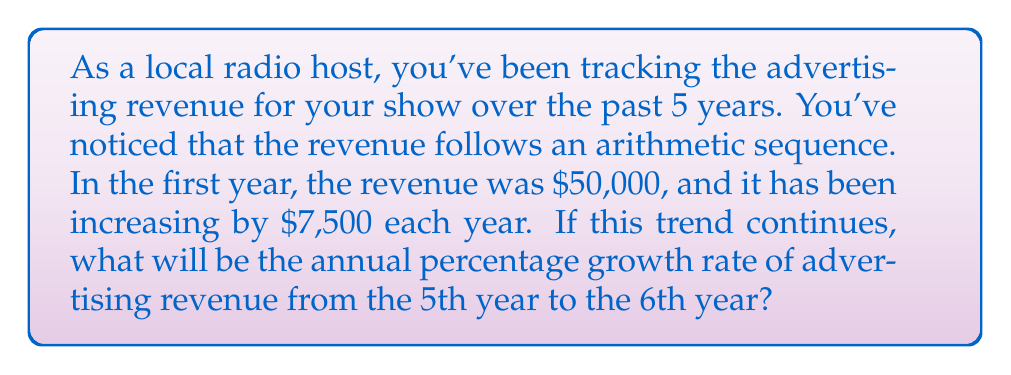What is the answer to this math problem? Let's approach this step-by-step:

1) First, we need to find the revenue for the 5th and 6th years.

   The arithmetic sequence is given by:
   $$a_n = a_1 + (n-1)d$$
   where $a_n$ is the nth term, $a_1$ is the first term, $n$ is the term number, and $d$ is the common difference.

2) For the 5th year:
   $$a_5 = 50000 + (5-1) * 7500 = 50000 + 30000 = 80000$$

3) For the 6th year:
   $$a_6 = 50000 + (6-1) * 7500 = 50000 + 37500 = 87500$$

4) To calculate the percentage growth rate, we use the formula:
   $$\text{Growth Rate} = \frac{\text{New Value} - \text{Original Value}}{\text{Original Value}} * 100\%$$

5) Plugging in our values:
   $$\text{Growth Rate} = \frac{87500 - 80000}{80000} * 100\%$$
   $$= \frac{7500}{80000} * 100\%$$
   $$= 0.09375 * 100\%$$
   $$= 9.375\%$$

Therefore, the annual percentage growth rate from the 5th year to the 6th year is 9.375%.
Answer: 9.375% 